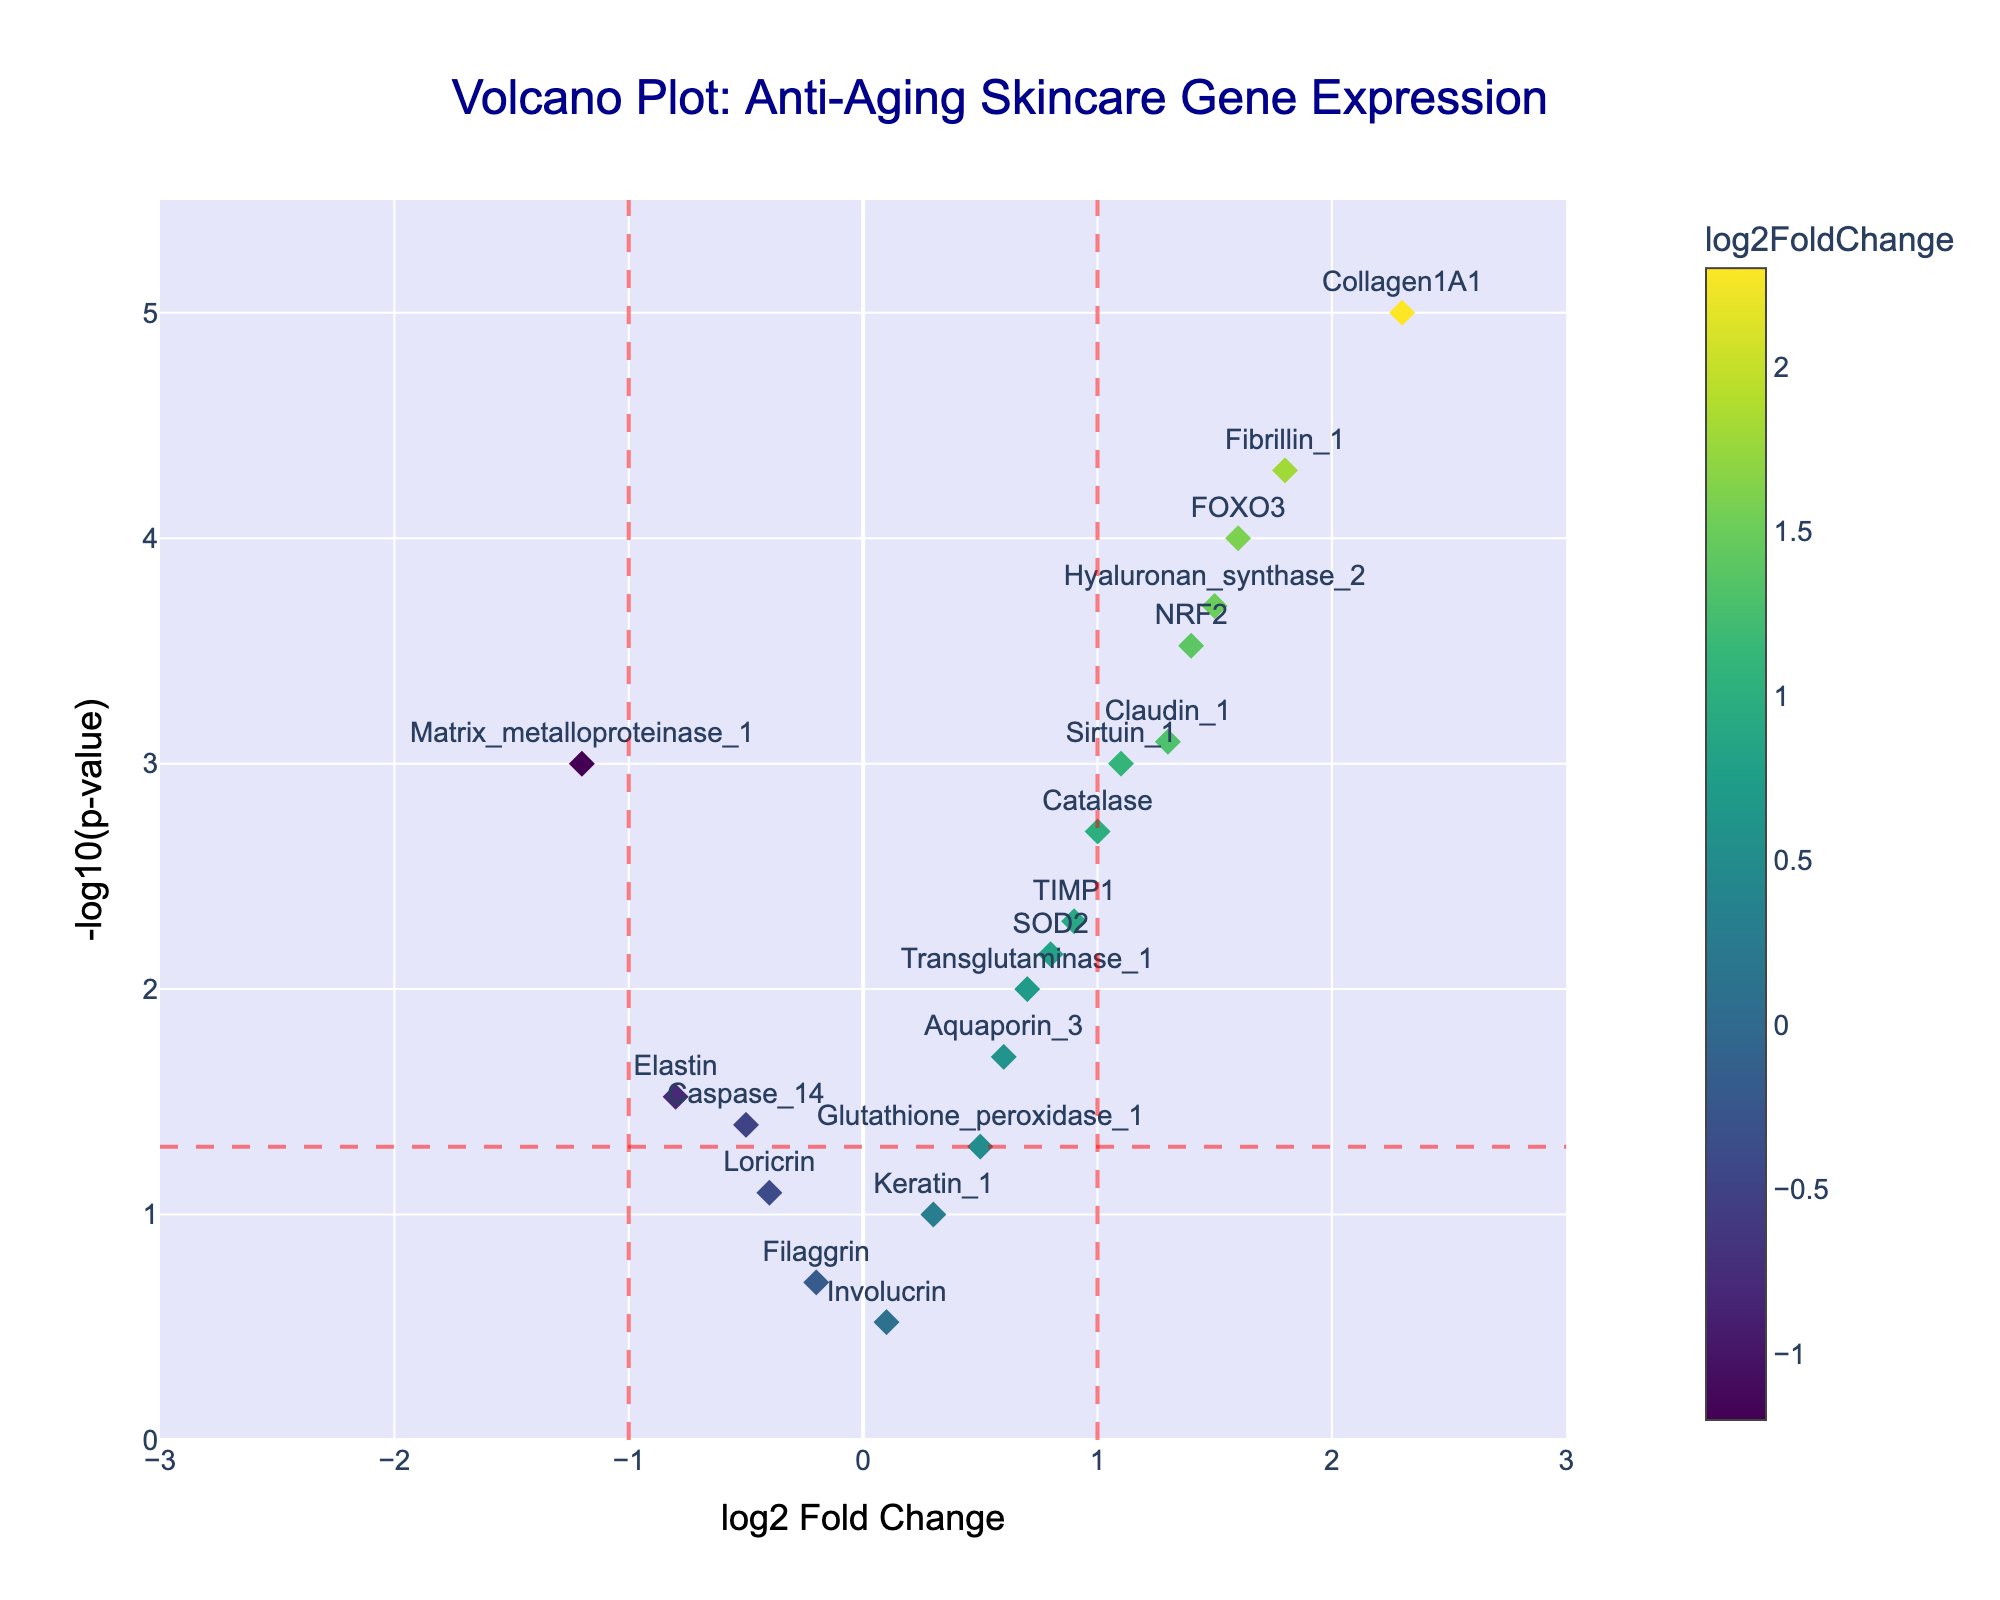What is the title of the plot? The title is located at the top of the plot and is usually in a larger font size for prominence. It helps convey the subject of the plot.
Answer: Volcano Plot: Anti-Aging Skincare Gene Expression Which gene has the highest log2 Fold Change? By looking at the x-axis, find the point farthest to the right. The associated gene label identifies the gene with the highest log2 Fold Change.
Answer: Collagen1A1 Which gene appears to be the most statistically significant? Check for the point with the highest y-value on the plot, indicating the smallest p-value (the lowest p-value translates to the highest -log10(p-value)). This gene label signifies the most statistically significant gene.
Answer: Collagen1A1 How many genes have a log2 Fold Change greater than 1? Count the number of points to the right of the vertical line at x=1. These points represent genes with a log2 Fold Change greater than 1.
Answer: 6 Which genes show a log2 Fold Change less than -1? Look to the left of the vertical line at x=-1 and identify the points. The labels next to these points indicate genes with a log2 Fold Change less than -1.
Answer: Matrix_metalloproteinase_1 Which gene has the smallest p-value but a negative log2 Fold Change? Observe the point with the highest y-value among all the points left of the line at x=0. The gene label here represents the gene with the smallest p-value but a negative log2 Fold Change.
Answer: Matrix_metalloproteinase_1 How many genes have a p-value less than 0.01? Examine the horizontal line y = -log10(0.01) and count the points above this line. These points represent genes with a p-value less than 0.01.
Answer: 9 Which genes have a log2 Fold Change between -0.5 and 0.5 and are not statistically significant (p-value > 0.05)? Identify points between x = -0.5 and x = 0.5 and below the horizontal line y = -log10(0.05). These points' labels indicate genes with log2 Fold Change between -0.5 and 0.5 and p-value > 0.05.
Answer: Filaggrin, Involucrin, Loricrin Which gene with a positive log2 Fold Change has the highest p-value? Look to the right of the vertical line at x=0 and find the point with the lowest y-value (representing the highest p-value). The label next to this point identifies the gene.
Answer: Aquaporin_3 How many genes have both a log2 Fold Change greater than 1 and a p-value less than 0.05? Check the region to the right of the vertical line x=1 and above the horizontal line y=-log10(0.05). Count the points in this region.
Answer: 5 